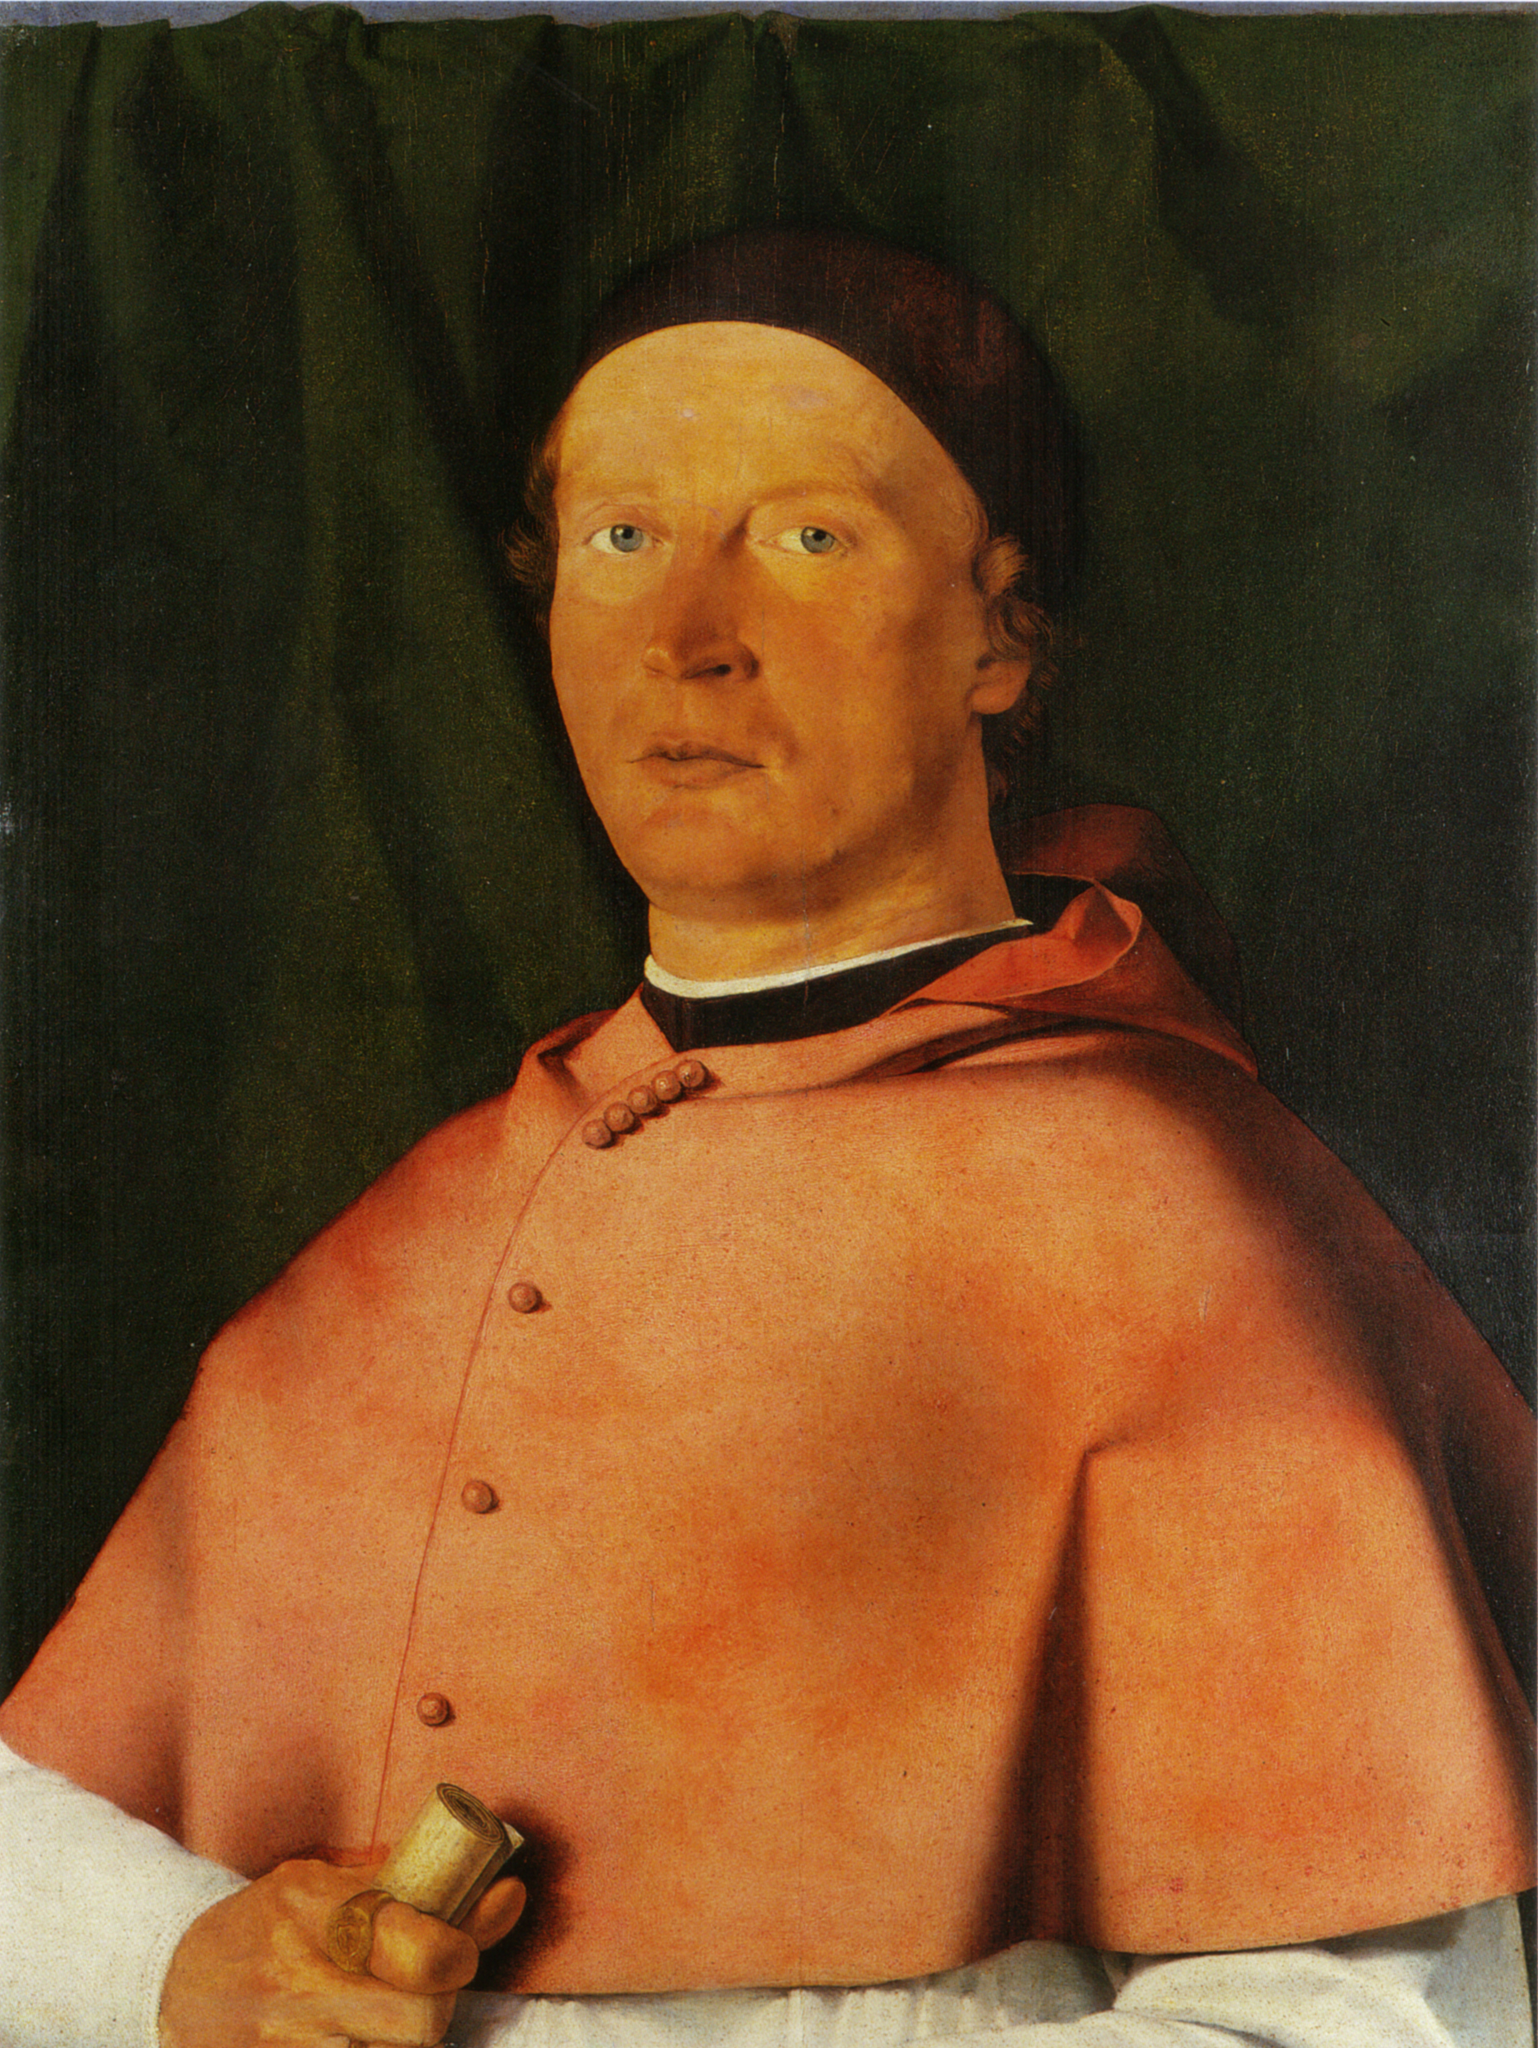What do you think is going on in this snapshot? This painting captures a man of likely significant status, as denoted by his luxurious red robe and the crafted gold object in his grasp. He appears contemplative, almost as if he has been momentarily distracted from profound thought, engaging the viewer with direct eye contact. The backdrop, a subdued green curtain, adds to the solemn and introspective mood of the portrait. The precise brushwork, from the intricate folds of his garment to the careful rendering of his facial features, hints at the artist's masterful technique, suggesting this work may originate from the Northern Renaissance period. The portrait is not merely a visual record but a crafted narrative, inviting us to ponder the man’s identity, his thoughts, and his place in history. 